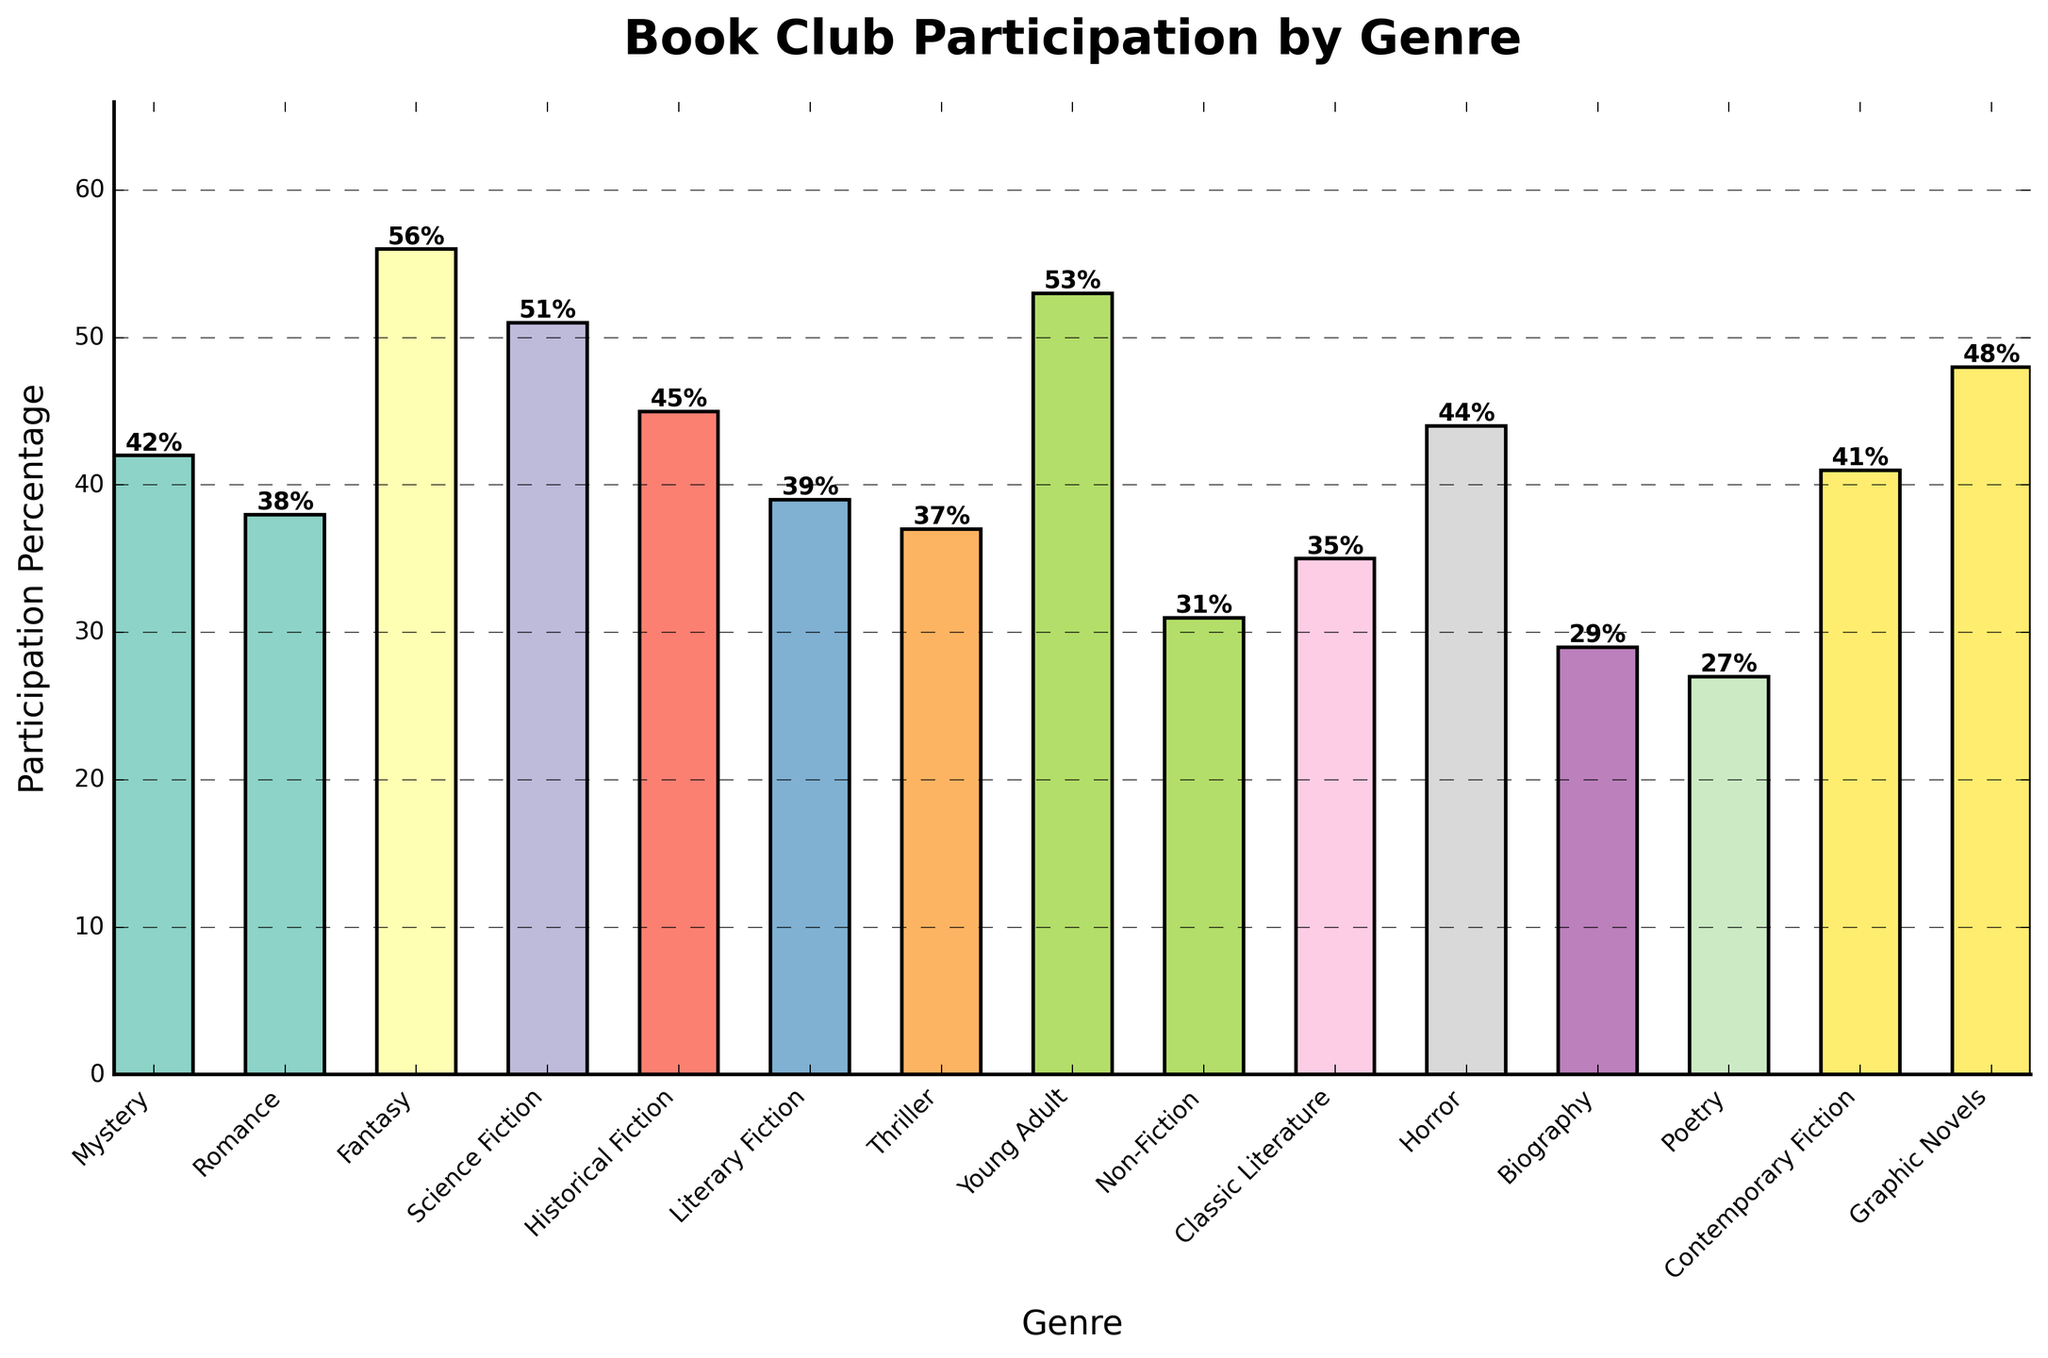Which genre has the highest participation percentage in book clubs? The tallest bar represents the highest participation percentage. "Fantasy" has the tallest bar at 56%.
Answer: Fantasy Which genre has the lowest participation percentage in book clubs? The shortest bar represents the lowest participation percentage. "Poetry" has the shortest bar at 27%.
Answer: Poetry Compare the participation percentages for Historical Fiction and Horror genres. Which is higher? By comparing the heights of the bars for Historical Fiction (45%) and Horror (44%), Historical Fiction has a slightly taller bar.
Answer: Historical Fiction What is the difference in participation percentages between Science Fiction and Romance? The bar for Science Fiction is at 51% and the bar for Romance is at 38%. The difference is 51% - 38% = 13%.
Answer: 13% Among Young Adult, Graphic Novels, and Non-Fiction, which genre has the middle value in participation percentage? Young Adult has 53%, Graphic Novels 48%, and Non-Fiction 31%. The middle value among these three is 48%.
Answer: Graphic Novels What is the average participation percentage for Classic Literature, Contemporary Fiction, and Literary Fiction? Adding the participation percentages: 35% (Classic Literature) + 41% (Contemporary Fiction) + 39% (Literary Fiction) = 115%. The average is 115% / 3 = 38.33%.
Answer: 38.33% How many genres have a participation percentage of 50% or greater? Counting the bars that reach 50% or higher: Fantasy (56%), Science Fiction (51%), Young Adult (53%).
Answer: 3 Which genre’s participation percentage is closest to 40%? Checking the bars near 40%: Romance (38%), Literary Fiction (39%), Contemporary Fiction (41%). The closest to 40% is Contemporary Fiction at 41%.
Answer: Contemporary Fiction What is the total participation percentage for all the genres combined? Sum of all percentages: 42 + 38 + 56 + 51 + 45 + 39 + 37 + 53 + 31 + 35 + 44 + 29 + 27 + 41 + 48. The total is 616%.
Answer: 616% By how many percentage points does Fantasy exceed Thriller in participation? Fantasy has a participation of 56% while Thriller stands at 37%. The difference is 56% - 37% = 19%.
Answer: 19% 